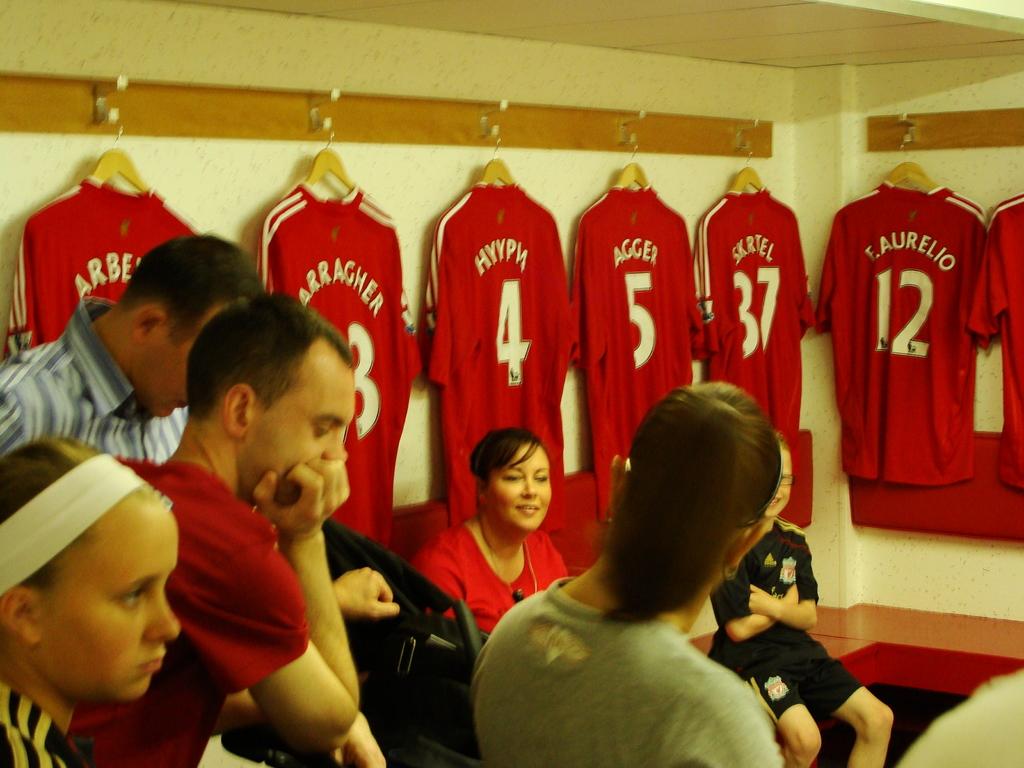Which player wears the number 12 jersey?
Ensure brevity in your answer.  F. aurelio. 